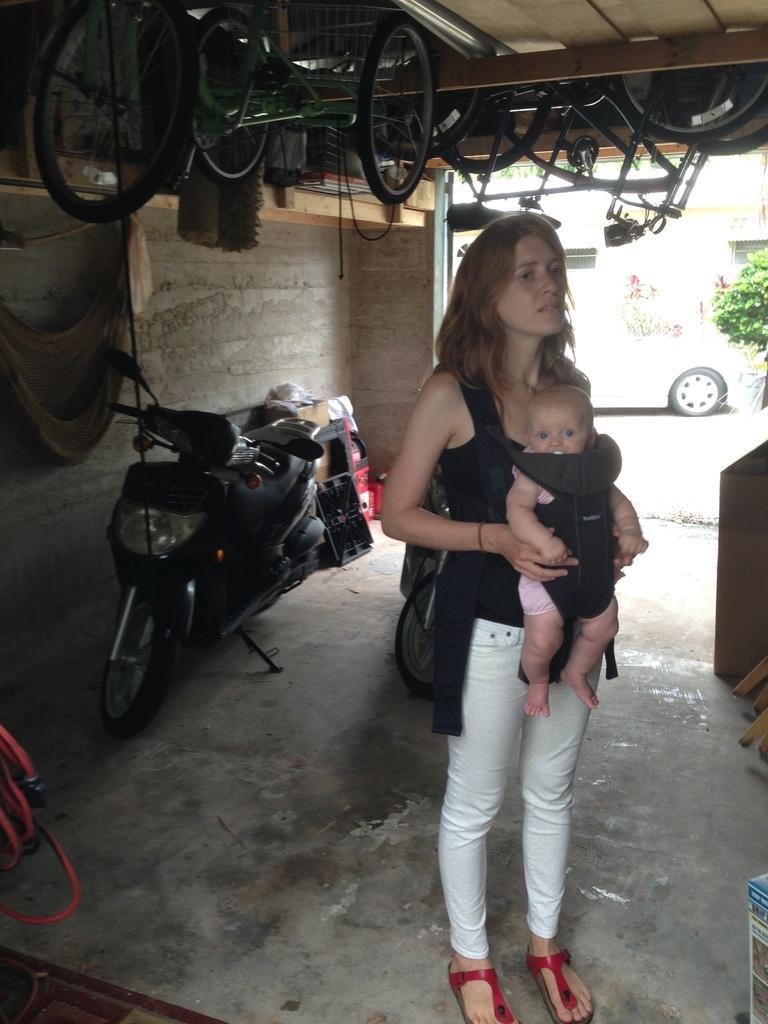Can you describe this image briefly? In this picture we can see a woman standing and carrying a baby, we can see two bikes here, in the background there is a car, we can see some wheels at the top of the picture, on the right side there is a plant. 